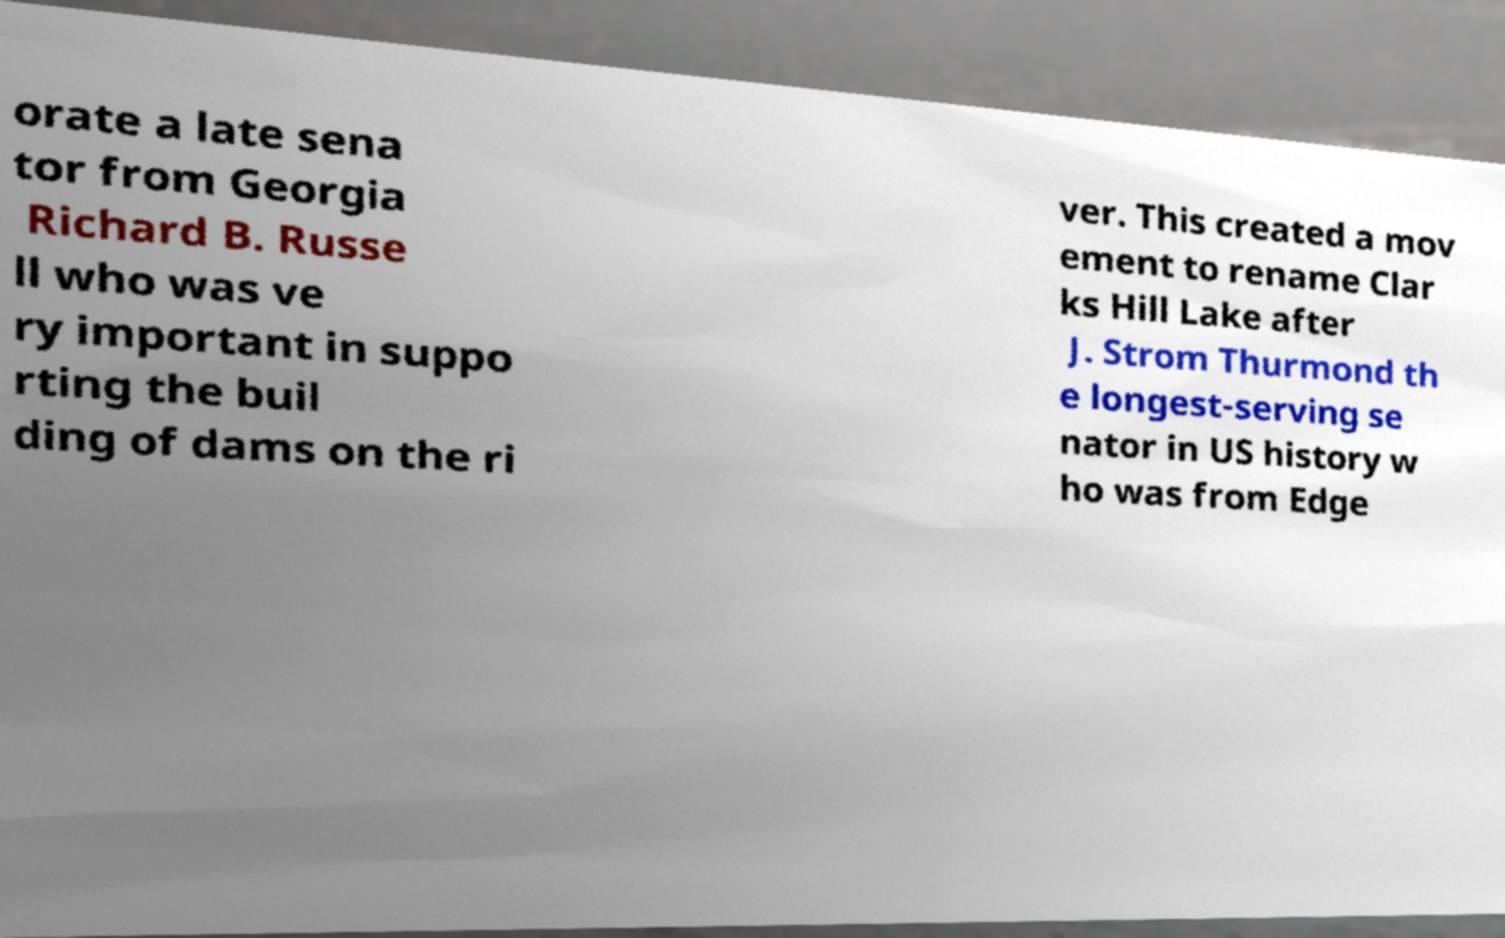I need the written content from this picture converted into text. Can you do that? orate a late sena tor from Georgia Richard B. Russe ll who was ve ry important in suppo rting the buil ding of dams on the ri ver. This created a mov ement to rename Clar ks Hill Lake after J. Strom Thurmond th e longest-serving se nator in US history w ho was from Edge 